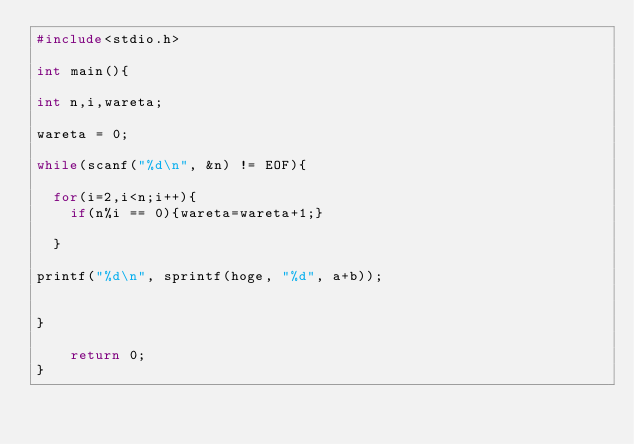Convert code to text. <code><loc_0><loc_0><loc_500><loc_500><_C_>#include<stdio.h>
   
int main(){
   
int n,i,wareta;

wareta = 0;
 
while(scanf("%d\n", &n) != EOF){
 
  for(i=2,i<n;i++){
    if(n%i == 0){wareta=wareta+1;}  

  } 

printf("%d\n", sprintf(hoge, "%d", a+b));
 
 
}
   
    return 0;
}</code> 